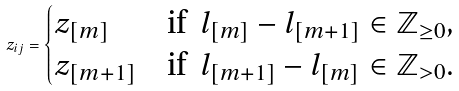Convert formula to latex. <formula><loc_0><loc_0><loc_500><loc_500>z _ { i j } = \begin{cases} z _ { [ m ] } & \text {if} \ \ l _ { [ m ] } - l _ { [ m + 1 ] } \in \mathbb { Z } _ { \geq 0 } , \\ z _ { [ m + 1 ] } & \text {if} \ \ l _ { [ m + 1 ] } - l _ { [ m ] } \in \mathbb { Z } _ { > 0 } . \end{cases}</formula> 